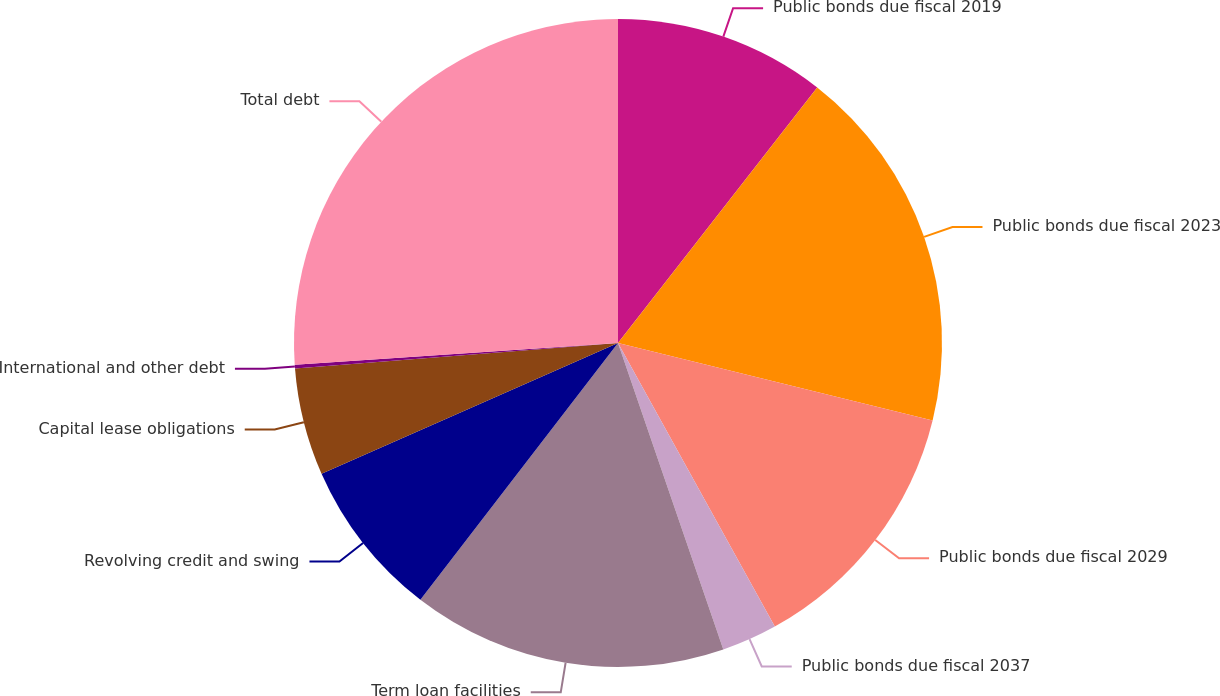<chart> <loc_0><loc_0><loc_500><loc_500><pie_chart><fcel>Public bonds due fiscal 2019<fcel>Public bonds due fiscal 2023<fcel>Public bonds due fiscal 2029<fcel>Public bonds due fiscal 2037<fcel>Term loan facilities<fcel>Revolving credit and swing<fcel>Capital lease obligations<fcel>International and other debt<fcel>Total debt<nl><fcel>10.54%<fcel>18.3%<fcel>13.12%<fcel>2.77%<fcel>15.71%<fcel>7.95%<fcel>5.36%<fcel>0.18%<fcel>26.07%<nl></chart> 